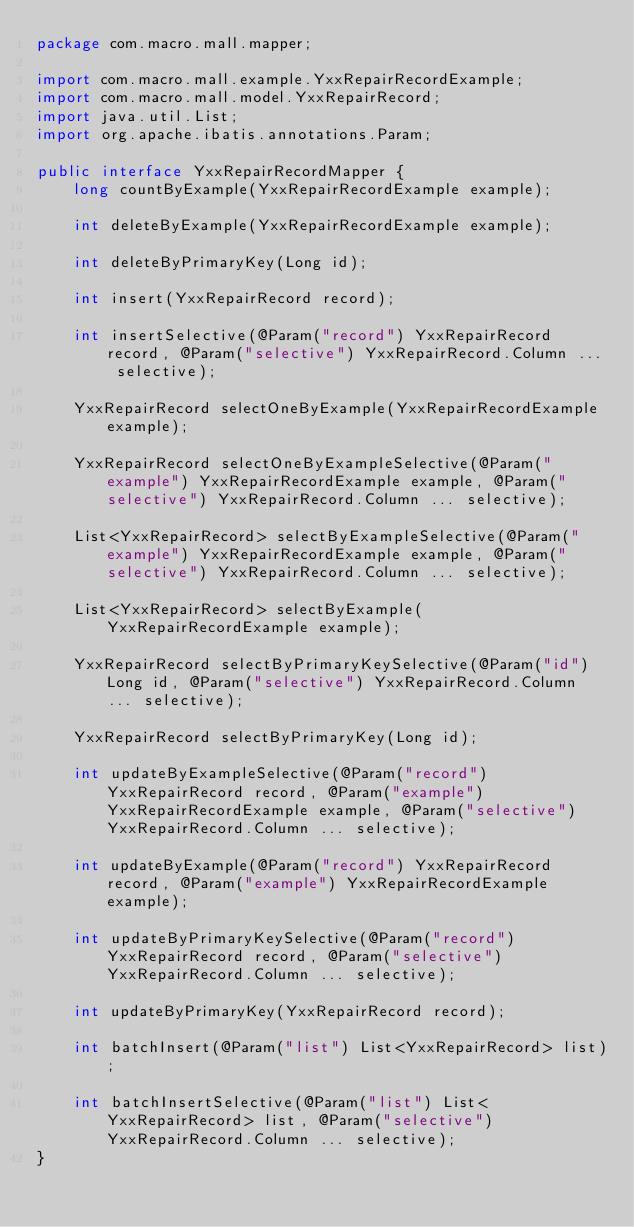<code> <loc_0><loc_0><loc_500><loc_500><_Java_>package com.macro.mall.mapper;

import com.macro.mall.example.YxxRepairRecordExample;
import com.macro.mall.model.YxxRepairRecord;
import java.util.List;
import org.apache.ibatis.annotations.Param;

public interface YxxRepairRecordMapper {
    long countByExample(YxxRepairRecordExample example);

    int deleteByExample(YxxRepairRecordExample example);

    int deleteByPrimaryKey(Long id);

    int insert(YxxRepairRecord record);

    int insertSelective(@Param("record") YxxRepairRecord record, @Param("selective") YxxRepairRecord.Column ... selective);

    YxxRepairRecord selectOneByExample(YxxRepairRecordExample example);

    YxxRepairRecord selectOneByExampleSelective(@Param("example") YxxRepairRecordExample example, @Param("selective") YxxRepairRecord.Column ... selective);

    List<YxxRepairRecord> selectByExampleSelective(@Param("example") YxxRepairRecordExample example, @Param("selective") YxxRepairRecord.Column ... selective);

    List<YxxRepairRecord> selectByExample(YxxRepairRecordExample example);

    YxxRepairRecord selectByPrimaryKeySelective(@Param("id") Long id, @Param("selective") YxxRepairRecord.Column ... selective);

    YxxRepairRecord selectByPrimaryKey(Long id);

    int updateByExampleSelective(@Param("record") YxxRepairRecord record, @Param("example") YxxRepairRecordExample example, @Param("selective") YxxRepairRecord.Column ... selective);

    int updateByExample(@Param("record") YxxRepairRecord record, @Param("example") YxxRepairRecordExample example);

    int updateByPrimaryKeySelective(@Param("record") YxxRepairRecord record, @Param("selective") YxxRepairRecord.Column ... selective);

    int updateByPrimaryKey(YxxRepairRecord record);

    int batchInsert(@Param("list") List<YxxRepairRecord> list);

    int batchInsertSelective(@Param("list") List<YxxRepairRecord> list, @Param("selective") YxxRepairRecord.Column ... selective);
}</code> 